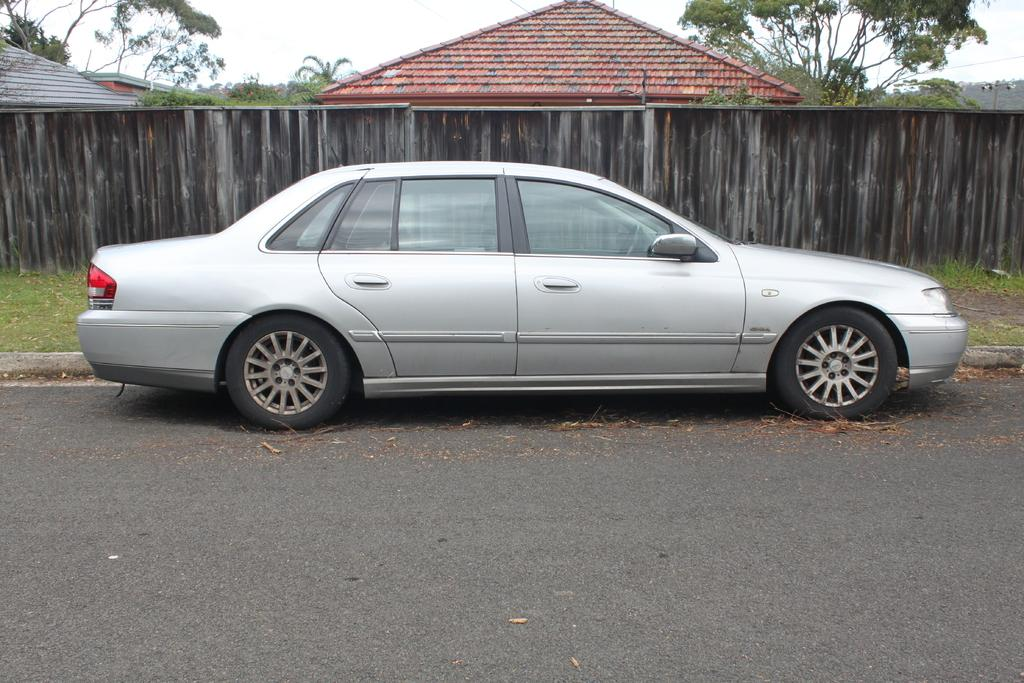What is the main subject of the image? The main subject of the image is a car. Where is the car located in the image? The car is on the road in the image. What can be seen in the background of the image? There are sheds, a fence, trees, and the sky visible in the background of the image. How many feet are required to join the car and the fence in the image? There is no need to join the car and the fence in the image, as they are separate objects. Additionally, feet are not used for joining objects in this context. 